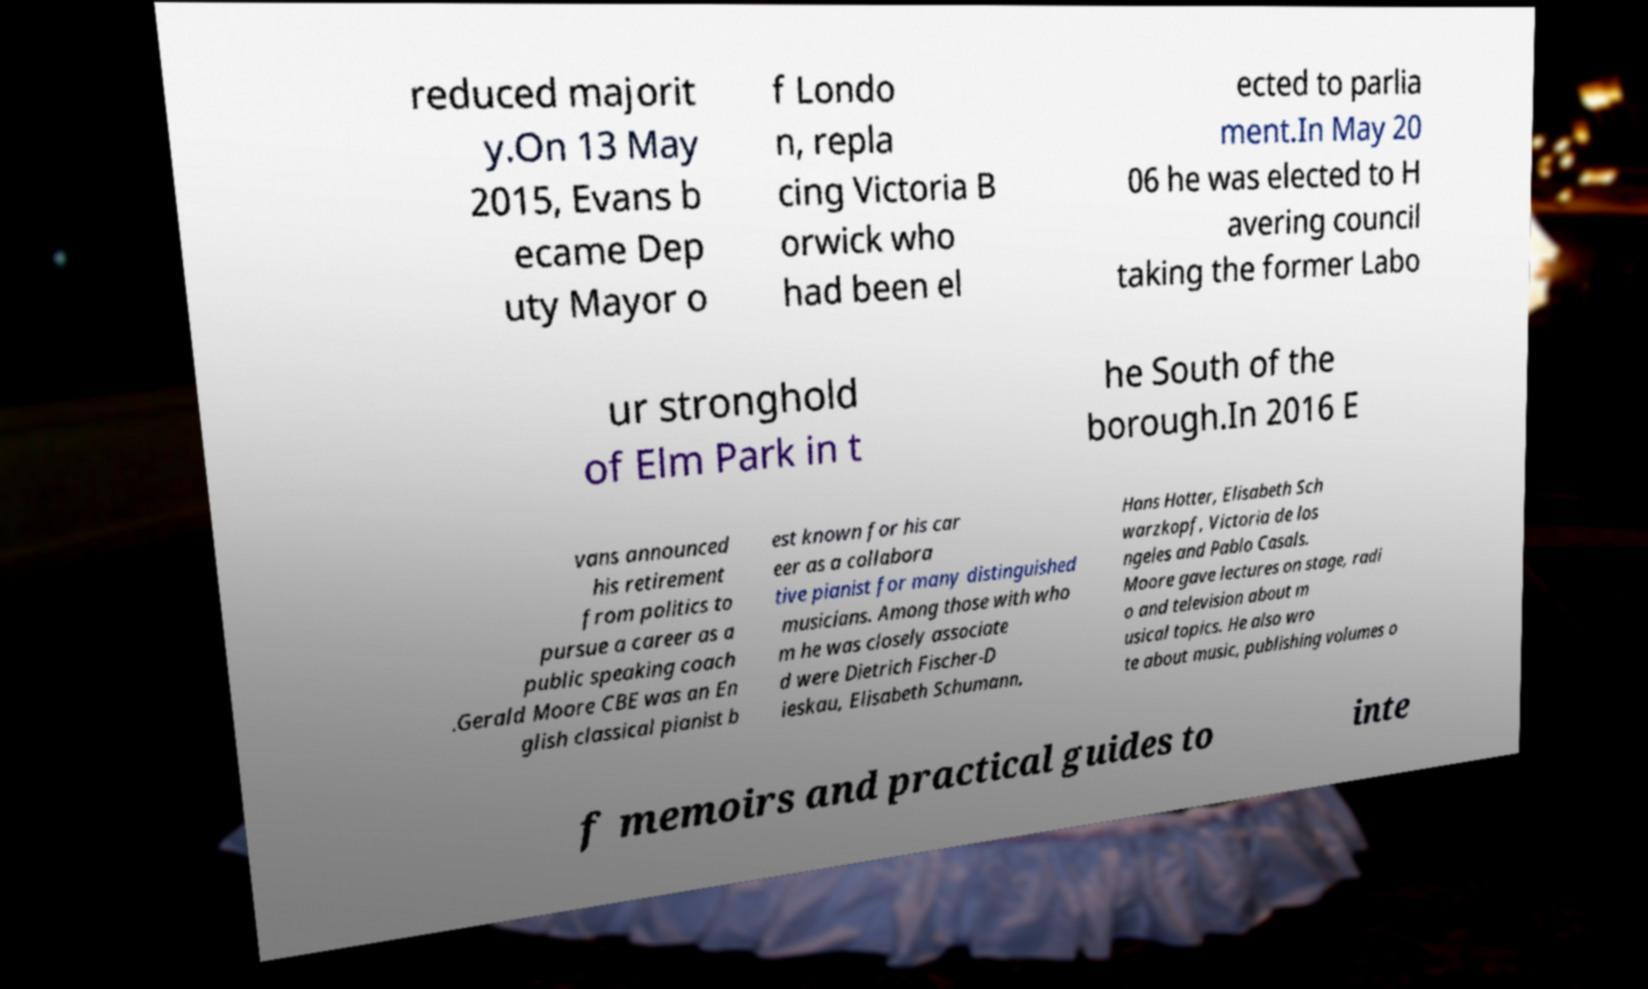Can you read and provide the text displayed in the image?This photo seems to have some interesting text. Can you extract and type it out for me? reduced majorit y.On 13 May 2015, Evans b ecame Dep uty Mayor o f Londo n, repla cing Victoria B orwick who had been el ected to parlia ment.In May 20 06 he was elected to H avering council taking the former Labo ur stronghold of Elm Park in t he South of the borough.In 2016 E vans announced his retirement from politics to pursue a career as a public speaking coach .Gerald Moore CBE was an En glish classical pianist b est known for his car eer as a collabora tive pianist for many distinguished musicians. Among those with who m he was closely associate d were Dietrich Fischer-D ieskau, Elisabeth Schumann, Hans Hotter, Elisabeth Sch warzkopf, Victoria de los ngeles and Pablo Casals. Moore gave lectures on stage, radi o and television about m usical topics. He also wro te about music, publishing volumes o f memoirs and practical guides to inte 